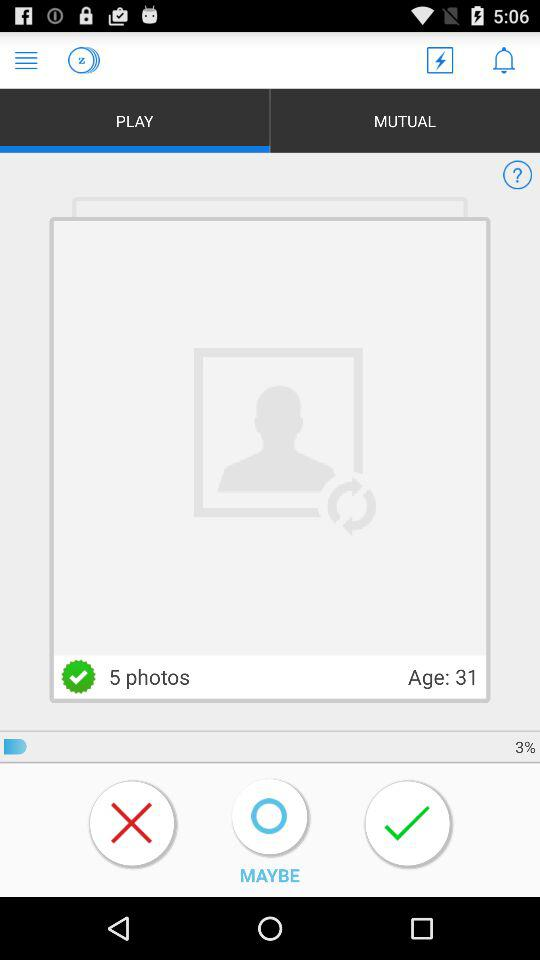What is the number of photos? The number of photos is 5. 